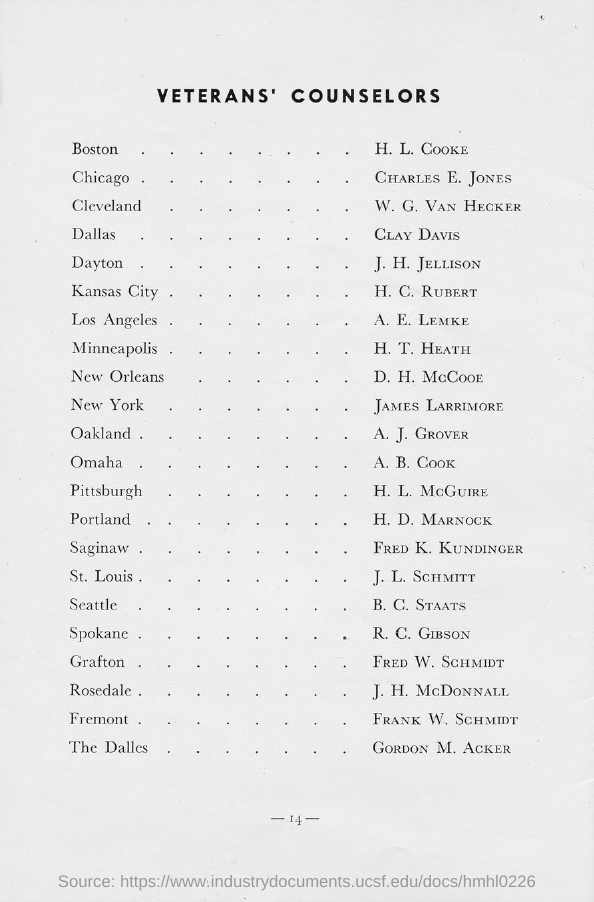Indicate a few pertinent items in this graphic. The title of the document is "Veteran's Counselors. 